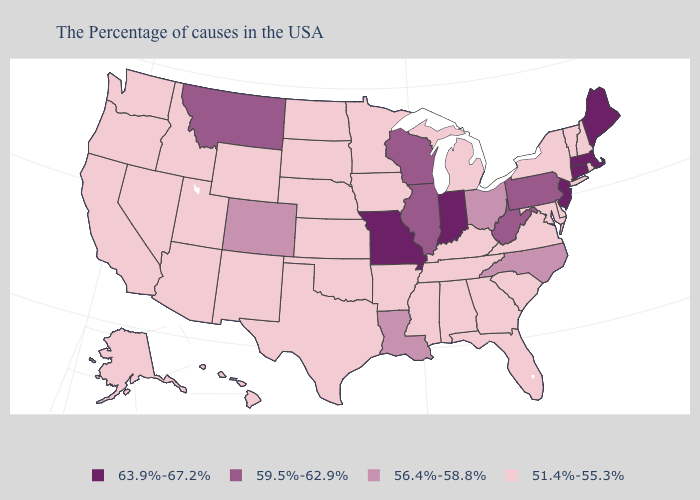Which states hav the highest value in the West?
Short answer required. Montana. What is the highest value in the West ?
Concise answer only. 59.5%-62.9%. Which states hav the highest value in the Northeast?
Give a very brief answer. Maine, Massachusetts, Connecticut, New Jersey. What is the value of Montana?
Give a very brief answer. 59.5%-62.9%. Name the states that have a value in the range 51.4%-55.3%?
Quick response, please. Rhode Island, New Hampshire, Vermont, New York, Delaware, Maryland, Virginia, South Carolina, Florida, Georgia, Michigan, Kentucky, Alabama, Tennessee, Mississippi, Arkansas, Minnesota, Iowa, Kansas, Nebraska, Oklahoma, Texas, South Dakota, North Dakota, Wyoming, New Mexico, Utah, Arizona, Idaho, Nevada, California, Washington, Oregon, Alaska, Hawaii. Does West Virginia have the highest value in the South?
Answer briefly. Yes. Does the map have missing data?
Write a very short answer. No. Name the states that have a value in the range 63.9%-67.2%?
Answer briefly. Maine, Massachusetts, Connecticut, New Jersey, Indiana, Missouri. What is the lowest value in states that border Oklahoma?
Short answer required. 51.4%-55.3%. What is the lowest value in states that border Kentucky?
Be succinct. 51.4%-55.3%. What is the lowest value in the MidWest?
Quick response, please. 51.4%-55.3%. What is the highest value in the South ?
Concise answer only. 59.5%-62.9%. Name the states that have a value in the range 56.4%-58.8%?
Concise answer only. North Carolina, Ohio, Louisiana, Colorado. Which states have the lowest value in the South?
Write a very short answer. Delaware, Maryland, Virginia, South Carolina, Florida, Georgia, Kentucky, Alabama, Tennessee, Mississippi, Arkansas, Oklahoma, Texas. 